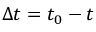<formula> <loc_0><loc_0><loc_500><loc_500>\Delta t = t _ { 0 } - t</formula> 